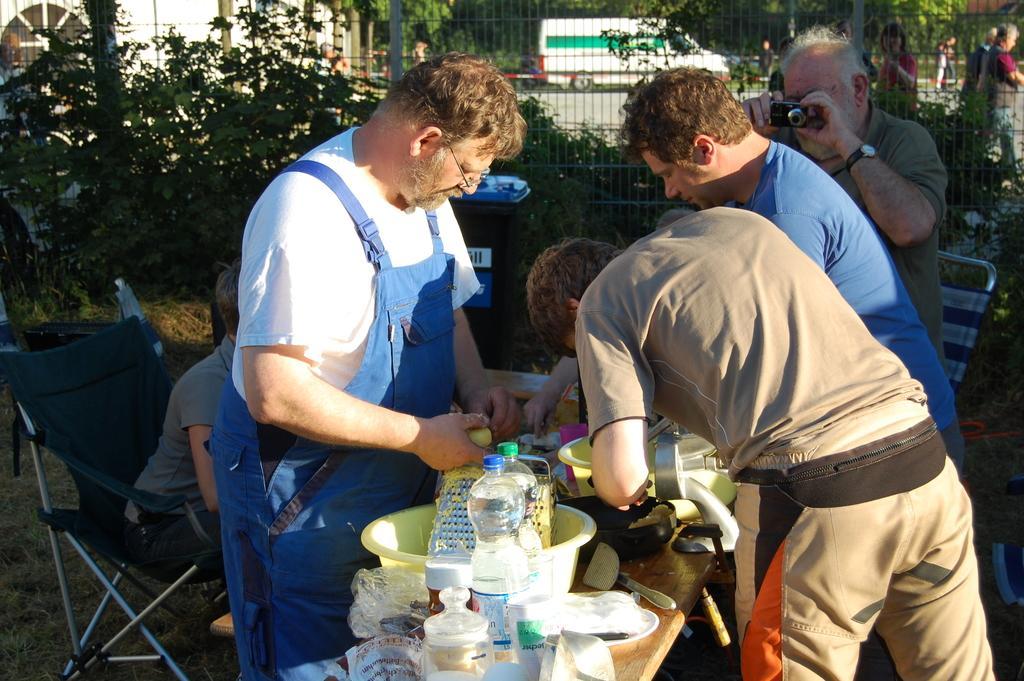Describe this image in one or two sentences. In this image I can see there are water bottles and other food items on this table. In the middle a man is trying to cook, he wore white color t-shirt. On the right side an old man is shooting with the camera, behind him there is an iron net and there are trees, at the top there is a vehicle in white color. 